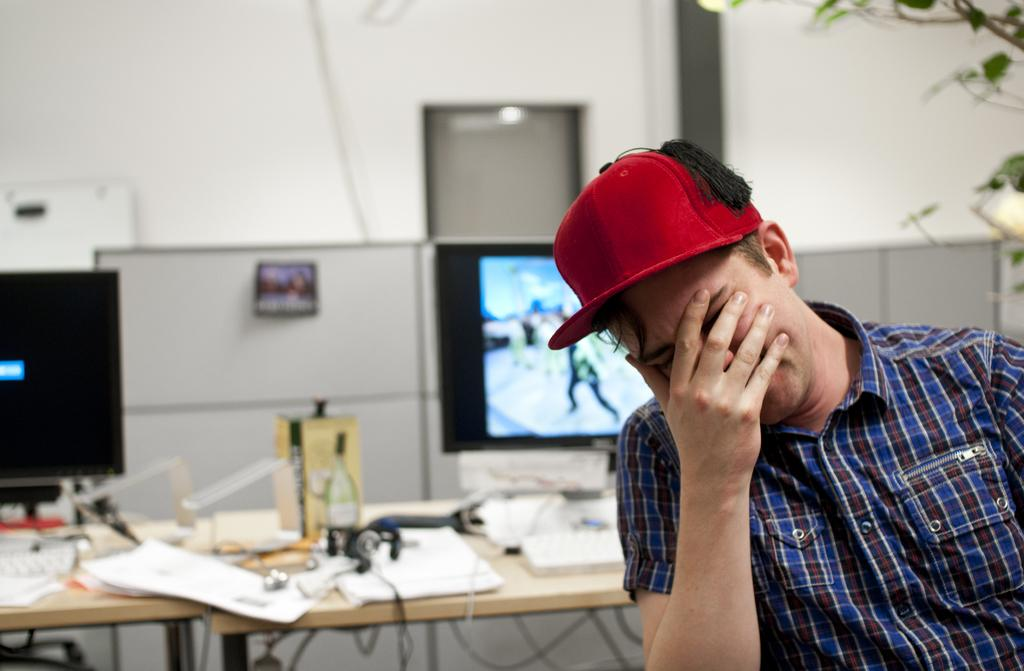Who is present in the image? There is a man in the picture. What is the man wearing on his head? The man is wearing a red cap. What can be seen on the table in the image? Papers, books, and other items are present on the table. What is visible in the background of the image? There is a display visible in the background. What type of ear is visible on the man in the image? The image does not show the man's ears; it only shows his red cap and the table with its contents. 